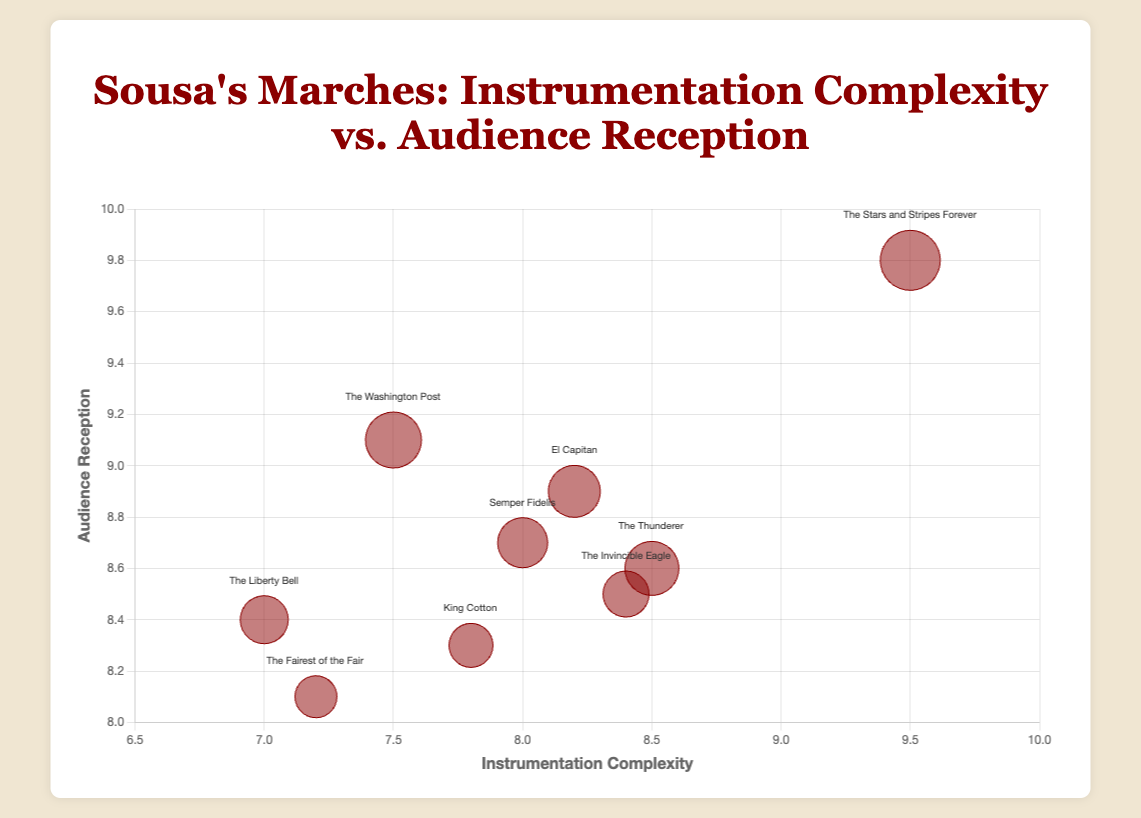What's the title of the chart? The chart's title is prominently displayed at the top of the figure and reads, "Sousa's Marches: Instrumentation Complexity vs. Audience Reception."
Answer: "Sousa's Marches: Instrumentation Complexity vs. Audience Reception" How many data points are shown in the chart? By counting the number of individual bubbles within the chart, you can determine that there are nine distinct data points.
Answer: 9 Which march has the highest instrumentation complexity, and what is its audience reception score? The march "The Stars and Stripes Forever" is placed the farthest to the right, indicating the highest instrumentation complexity score of 9.5. Its audience reception score is 9.8.
Answer: "The Stars and Stripes Forever" with an audience reception score of 9.8 What is the average audience reception score of the marches? Sum the audience reception scores: 9.8 + 8.7 + 9.1 + 8.4 + 8.9 + 8.6 + 8.3 + 8.1 + 8.5, which equals 78.4. Divide this by the number of marches (9) to get the average: 78.4 / 9 ≈ 8.71.
Answer: 8.71 Which two marches have the closest audience reception scores? By examining the y-axis positions closely, "The Thunderer" (8.6) and "The Invincible Eagle" (8.5) are very close, with a difference of just 0.1 between their audience reception scores.
Answer: "The Thunderer" and "The Invincible Eagle" Is there any march that has both below-average instrumentation complexity and audience reception scores? Calculate the average scores for both metrics: Instrumentation complexity = (9.5+8+7.5+7+8.2+8.5+7.8+7.2+8.4) / 9 = 7.89; Audience reception = 8.71. The march "The Fairest of the Fair" has both below-average scores (7.2 instrumentation complexity and 8.1 audience reception) compared to these averages.
Answer: "The Fairest of the Fair" Which bubble is the largest and what does it represent? The largest bubble has a size of 30, and it represents "The Stars and Stripes Forever," as indicated in the dataset.
Answer: "The Stars and Stripes Forever" Is there a noticeable correlation between instrumentation complexity and audience reception? By visually assessing the trend, most points with higher instrumentation complexity also have higher audience reception, suggesting a positive correlation.
Answer: Positive correlation Which march was performed most recently, and what are its complexity and reception scores? "The Fairest of the Fair" has the latest performance date of 1908. Its scores are 7.2 for instrumentation complexity and 8.1 for audience reception.
Answer: "The Fairest of the Fair," 7.2 complexity, 8.1 reception 